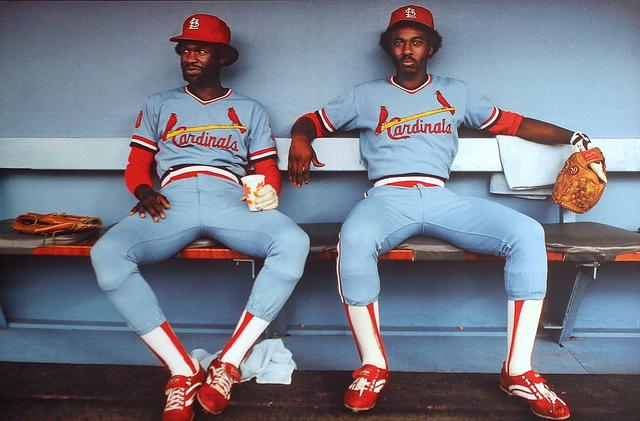Who played for this team? garry templeton 